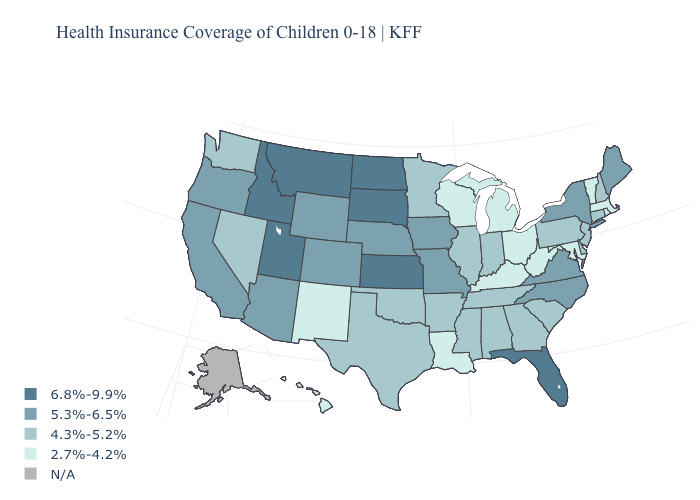What is the highest value in the MidWest ?
Concise answer only. 6.8%-9.9%. Does the first symbol in the legend represent the smallest category?
Write a very short answer. No. What is the highest value in the USA?
Answer briefly. 6.8%-9.9%. Does Florida have the lowest value in the USA?
Be succinct. No. Name the states that have a value in the range 4.3%-5.2%?
Short answer required. Alabama, Arkansas, Connecticut, Delaware, Georgia, Illinois, Indiana, Minnesota, Mississippi, Nevada, New Hampshire, New Jersey, Oklahoma, Pennsylvania, South Carolina, Tennessee, Texas, Washington. Name the states that have a value in the range 4.3%-5.2%?
Give a very brief answer. Alabama, Arkansas, Connecticut, Delaware, Georgia, Illinois, Indiana, Minnesota, Mississippi, Nevada, New Hampshire, New Jersey, Oklahoma, Pennsylvania, South Carolina, Tennessee, Texas, Washington. Does Wisconsin have the lowest value in the USA?
Give a very brief answer. Yes. What is the highest value in the USA?
Concise answer only. 6.8%-9.9%. What is the value of Hawaii?
Give a very brief answer. 2.7%-4.2%. Does the map have missing data?
Concise answer only. Yes. Among the states that border Louisiana , which have the lowest value?
Write a very short answer. Arkansas, Mississippi, Texas. Among the states that border North Dakota , does Minnesota have the highest value?
Concise answer only. No. What is the value of Texas?
Write a very short answer. 4.3%-5.2%. What is the highest value in the USA?
Keep it brief. 6.8%-9.9%. 